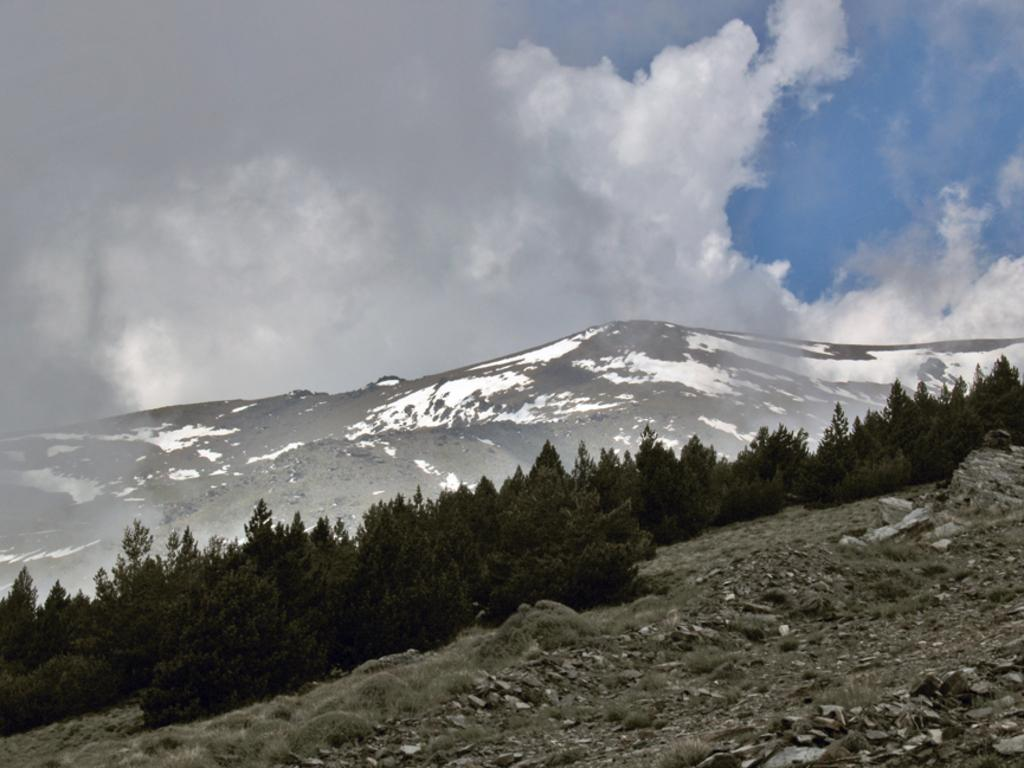What type of vegetation is present on the hill in the image? There are trees and grass on the hill in the image. What other objects can be seen on the hill? There are stones on the hill. What is visible in the background of the image? In the background, there is a snow hill. What is the condition of the sky in the image? The sky is blue with clouds visible. What type of knowledge is being shared among the trees on the hill? There is no indication in the image that the trees are sharing knowledge or engaging in any activity. --- Facts: 1. There is a person sitting on a bench. 2. The person is reading a book. 3. There is a tree behind the bench. 4. The ground is visible. 5. There is a fence in the background. Absurd Topics: dance, ocean, parrot Conversation: What is the person in the image doing? The person is sitting on a bench and reading a book. What object is the person using while sitting on the bench? The person is reading a book. What type of vegetation is visible in the image? There is a tree behind the bench. What is visible on the ground in the image? The ground is visible. What architectural feature can be seen in the background of the image? There is a fence in the background. Reasoning: Let's think step by step in order to produce the conversation. We start by identifying the main subject of the image, which is the person sitting on the bench. Then, we describe the activity the person is engaged in, which is reading a book. Next, we expand the conversation to include the surrounding environment, such as the tree, the ground, and the fence in the background. Absurd Question/Answer: What type of dance is being performed by the parrot in the image? There is no parrot present in the image, and therefore no such activity can be observed. 